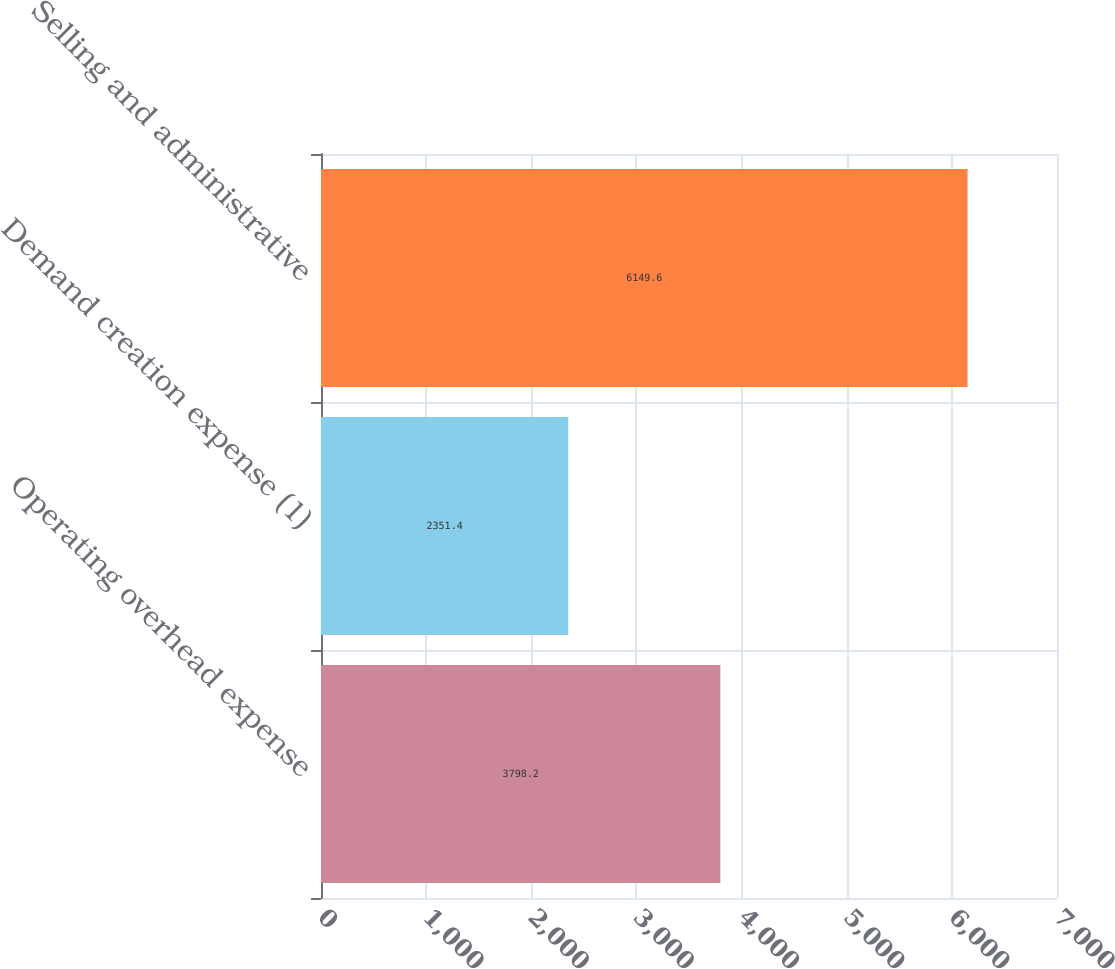<chart> <loc_0><loc_0><loc_500><loc_500><bar_chart><fcel>Operating overhead expense<fcel>Demand creation expense (1)<fcel>Selling and administrative<nl><fcel>3798.2<fcel>2351.4<fcel>6149.6<nl></chart> 